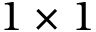Convert formula to latex. <formula><loc_0><loc_0><loc_500><loc_500>1 \times 1</formula> 